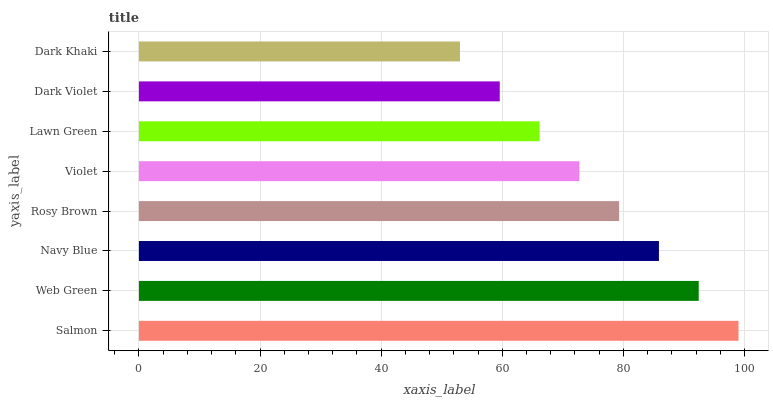Is Dark Khaki the minimum?
Answer yes or no. Yes. Is Salmon the maximum?
Answer yes or no. Yes. Is Web Green the minimum?
Answer yes or no. No. Is Web Green the maximum?
Answer yes or no. No. Is Salmon greater than Web Green?
Answer yes or no. Yes. Is Web Green less than Salmon?
Answer yes or no. Yes. Is Web Green greater than Salmon?
Answer yes or no. No. Is Salmon less than Web Green?
Answer yes or no. No. Is Rosy Brown the high median?
Answer yes or no. Yes. Is Violet the low median?
Answer yes or no. Yes. Is Violet the high median?
Answer yes or no. No. Is Lawn Green the low median?
Answer yes or no. No. 